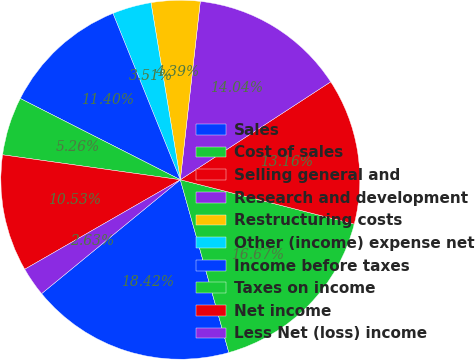<chart> <loc_0><loc_0><loc_500><loc_500><pie_chart><fcel>Sales<fcel>Cost of sales<fcel>Selling general and<fcel>Research and development<fcel>Restructuring costs<fcel>Other (income) expense net<fcel>Income before taxes<fcel>Taxes on income<fcel>Net income<fcel>Less Net (loss) income<nl><fcel>18.42%<fcel>16.67%<fcel>13.16%<fcel>14.04%<fcel>4.39%<fcel>3.51%<fcel>11.4%<fcel>5.26%<fcel>10.53%<fcel>2.63%<nl></chart> 